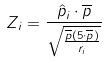Convert formula to latex. <formula><loc_0><loc_0><loc_500><loc_500>Z _ { i } = \frac { \hat { p } _ { i } \cdot \overline { p } } { \sqrt { \frac { \overline { p } ( 5 \cdot \overline { p } ) } { r _ { i } } } }</formula> 